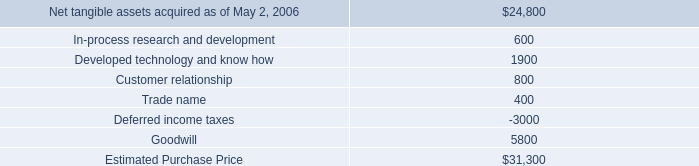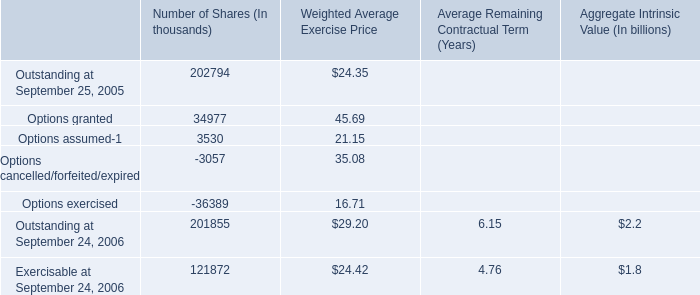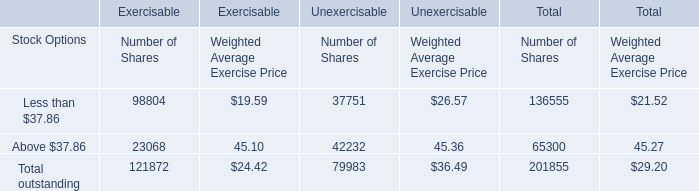what is the fair value of hologic common stock? 
Computations: (5300 / 110)
Answer: 48.18182. 